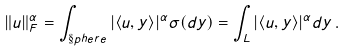Convert formula to latex. <formula><loc_0><loc_0><loc_500><loc_500>\| u \| _ { F } ^ { \alpha } = \int _ { \S p h e r e } | \langle u , y \rangle | ^ { \alpha } \sigma ( d y ) = \int _ { L } | \langle u , y \rangle | ^ { \alpha } d y \, .</formula> 